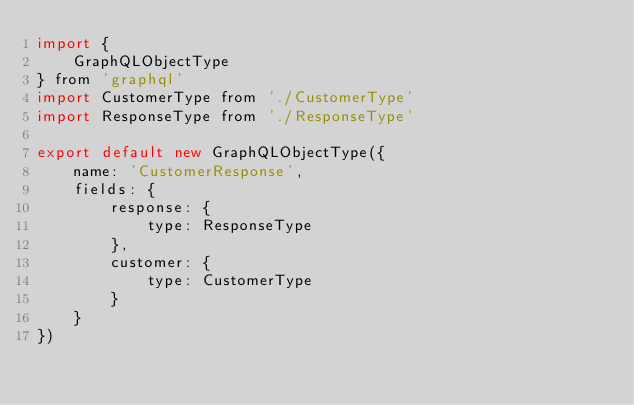<code> <loc_0><loc_0><loc_500><loc_500><_JavaScript_>import {
	GraphQLObjectType
} from 'graphql'
import CustomerType from './CustomerType'
import ResponseType from './ResponseType'

export default new GraphQLObjectType({
	name: 'CustomerResponse',
	fields: {
		response: {
			type: ResponseType
		},
		customer: {
			type: CustomerType
		}
	}
})
</code> 